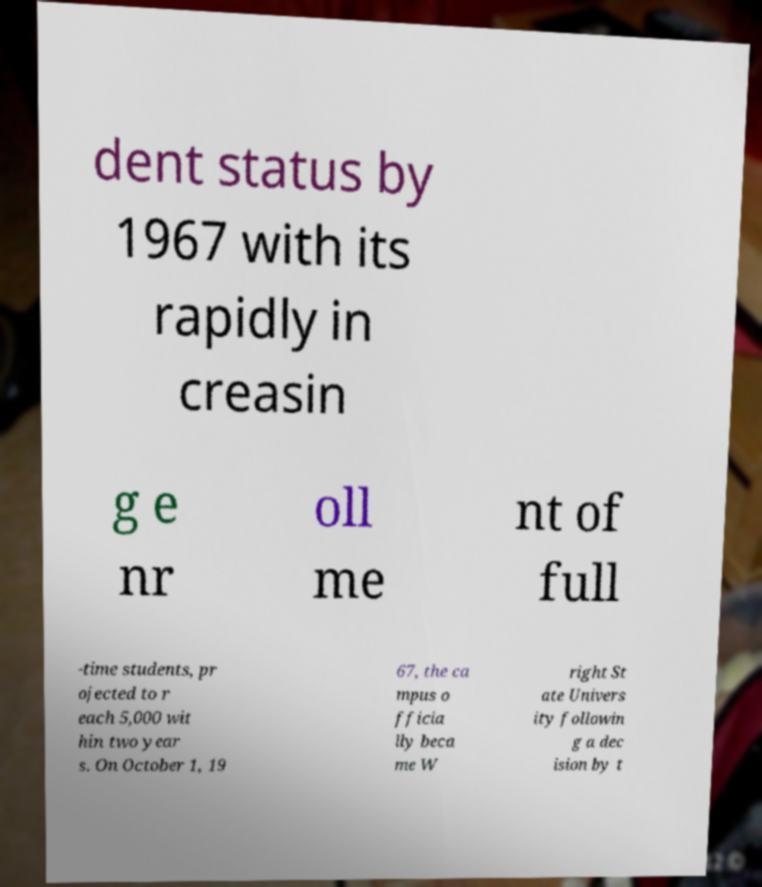There's text embedded in this image that I need extracted. Can you transcribe it verbatim? dent status by 1967 with its rapidly in creasin g e nr oll me nt of full -time students, pr ojected to r each 5,000 wit hin two year s. On October 1, 19 67, the ca mpus o fficia lly beca me W right St ate Univers ity followin g a dec ision by t 